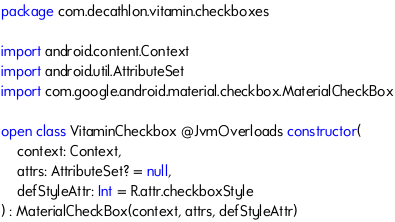<code> <loc_0><loc_0><loc_500><loc_500><_Kotlin_>package com.decathlon.vitamin.checkboxes

import android.content.Context
import android.util.AttributeSet
import com.google.android.material.checkbox.MaterialCheckBox

open class VitaminCheckbox @JvmOverloads constructor(
    context: Context,
    attrs: AttributeSet? = null,
    defStyleAttr: Int = R.attr.checkboxStyle
) : MaterialCheckBox(context, attrs, defStyleAttr)
</code> 